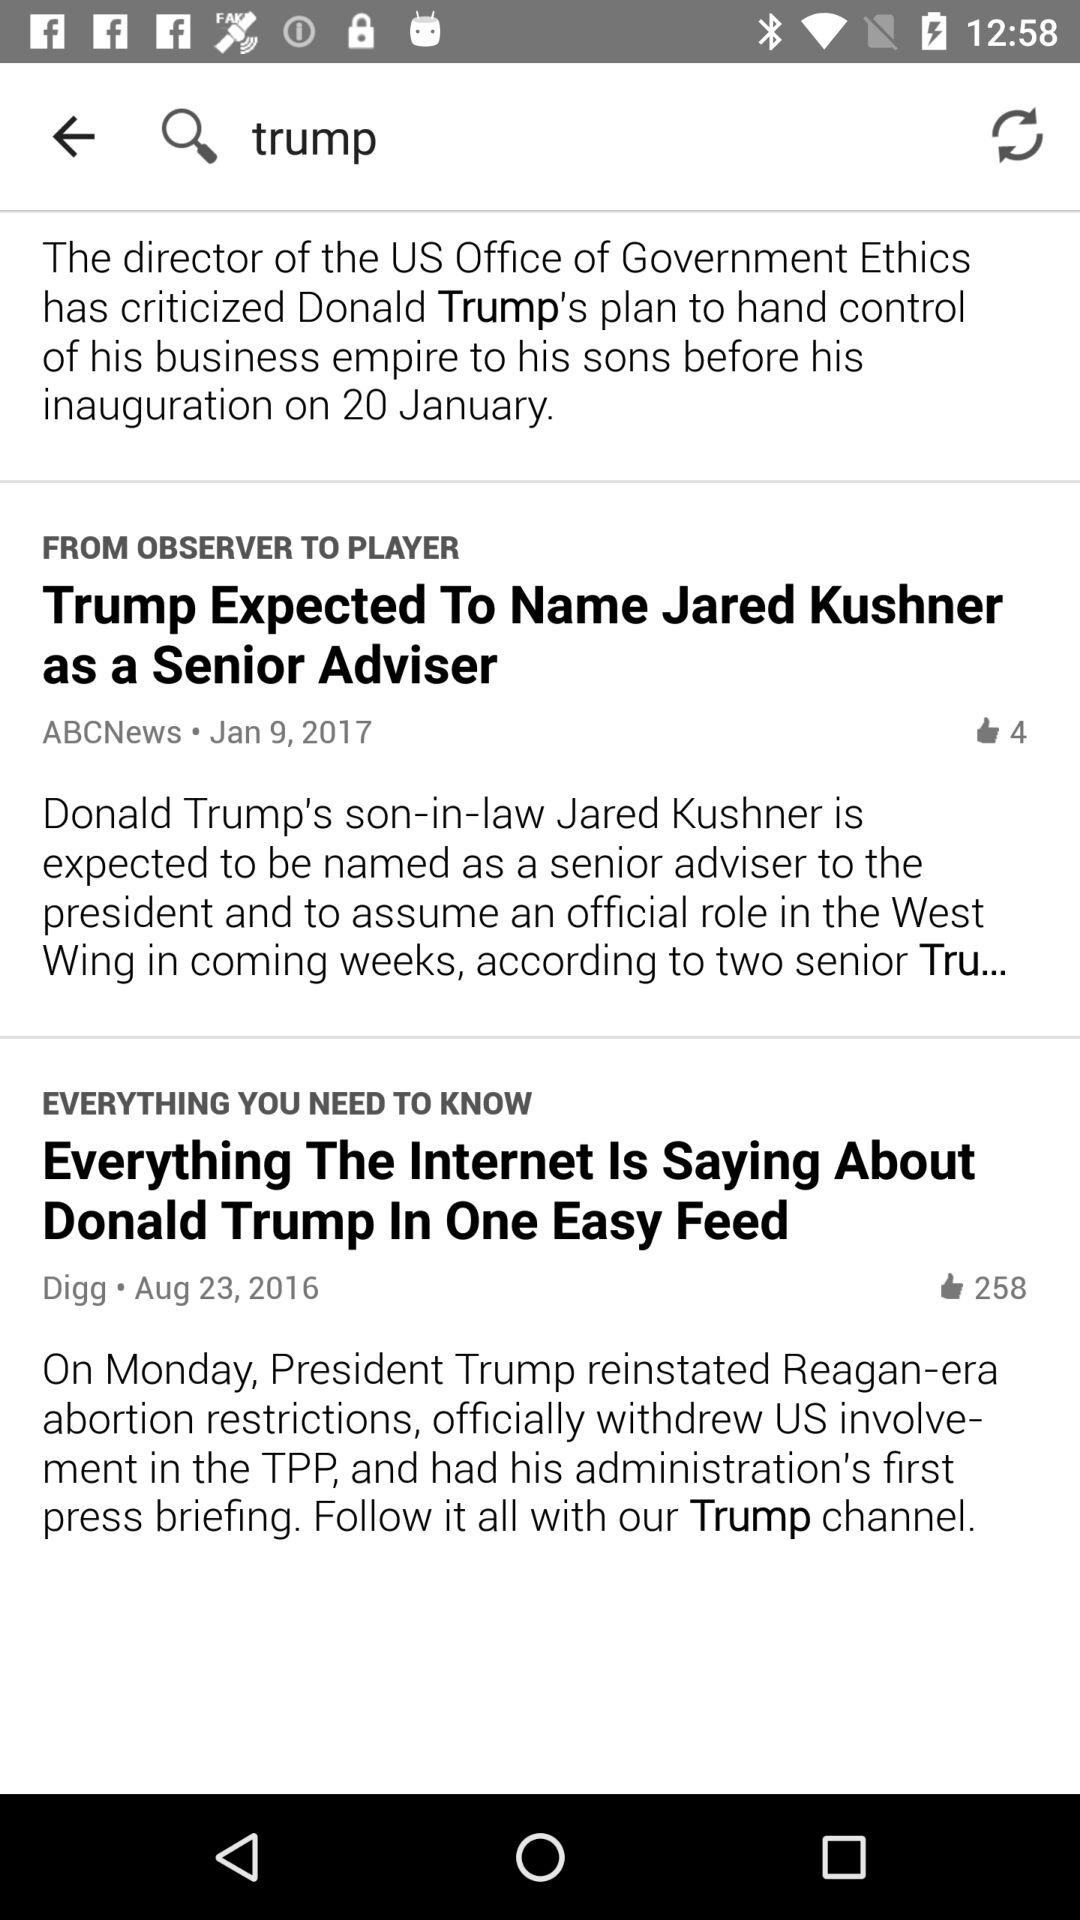What is the name of the application?
When the provided information is insufficient, respond with <no answer>. <no answer> 